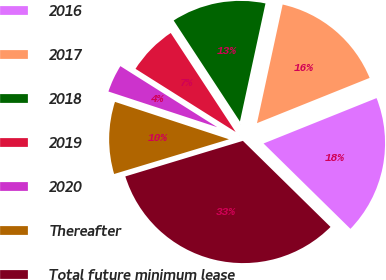Convert chart. <chart><loc_0><loc_0><loc_500><loc_500><pie_chart><fcel>2016<fcel>2017<fcel>2018<fcel>2019<fcel>2020<fcel>Thereafter<fcel>Total future minimum lease<nl><fcel>18.44%<fcel>15.53%<fcel>12.63%<fcel>6.81%<fcel>3.91%<fcel>9.72%<fcel>32.97%<nl></chart> 